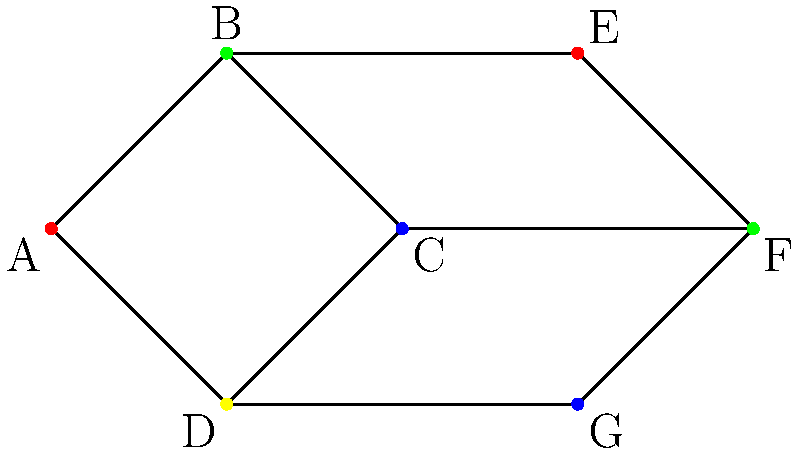In the graph coloring representation of drug compounds above, what is the chromatic number, and how might this impact the efficiency of drug discovery processes in a commercial pharmaceutical setting? To determine the chromatic number and its impact on drug discovery, we'll follow these steps:

1. Analyze the graph:
   - The graph represents drug compounds as vertices.
   - Edges connect compounds with similar properties or interactions.
   - Colors represent distinct classes or properties of compounds.

2. Count the colors used:
   - Red: vertices A and E
   - Green: vertices B and F
   - Blue: vertices C and G
   - Yellow: vertex D

3. Determine the chromatic number:
   - The chromatic number is the minimum number of colors needed to color the graph such that no adjacent vertices have the same color.
   - In this case, we see 4 colors used, and it's the minimum possible.
   - Therefore, the chromatic number is 4.

4. Impact on drug discovery in a commercial setting:
   - Efficiency: The chromatic number represents the minimum number of distinct classes or properties needed to categorize the compounds. A lower chromatic number means fewer categories to manage, potentially streamlining the discovery process.
   - Screening: Compounds of the same color can be screened together, reducing the number of separate tests required.
   - Resource allocation: Fewer categories (colors) allow for more focused resource allocation in research and development.
   - Data management: A lower chromatic number simplifies data structures and analysis algorithms, potentially speeding up computational processes in drug discovery.

5. Commercial implications:
   - Cost reduction: Fewer categories can lead to more efficient use of resources, potentially reducing R&D costs.
   - Time-to-market: Simplified categorization may accelerate the drug discovery pipeline, bringing products to market faster.
   - Competitive advantage: More efficient processes can give a company an edge in the highly competitive pharmaceutical industry.
Answer: Chromatic number: 4. Impact: Streamlines drug discovery by minimizing compound categories, potentially reducing costs and accelerating time-to-market in commercial pharmaceutical settings. 